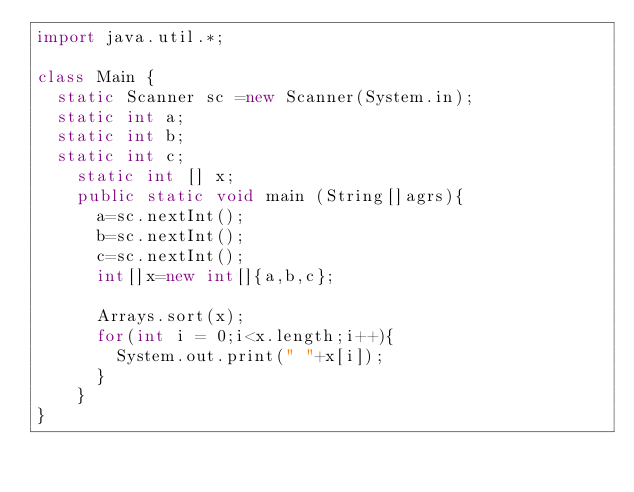Convert code to text. <code><loc_0><loc_0><loc_500><loc_500><_Java_>import java.util.*;

class Main {
	static Scanner sc =new Scanner(System.in);
	static int a;
	static int b;
	static int c;
    static int [] x;
		public static void main (String[]agrs){
			a=sc.nextInt();
			b=sc.nextInt();
			c=sc.nextInt();
			int[]x=new int[]{a,b,c};
			
			Arrays.sort(x);
			for(int i = 0;i<x.length;i++){
				System.out.print(" "+x[i]);
			}
		}
}</code> 